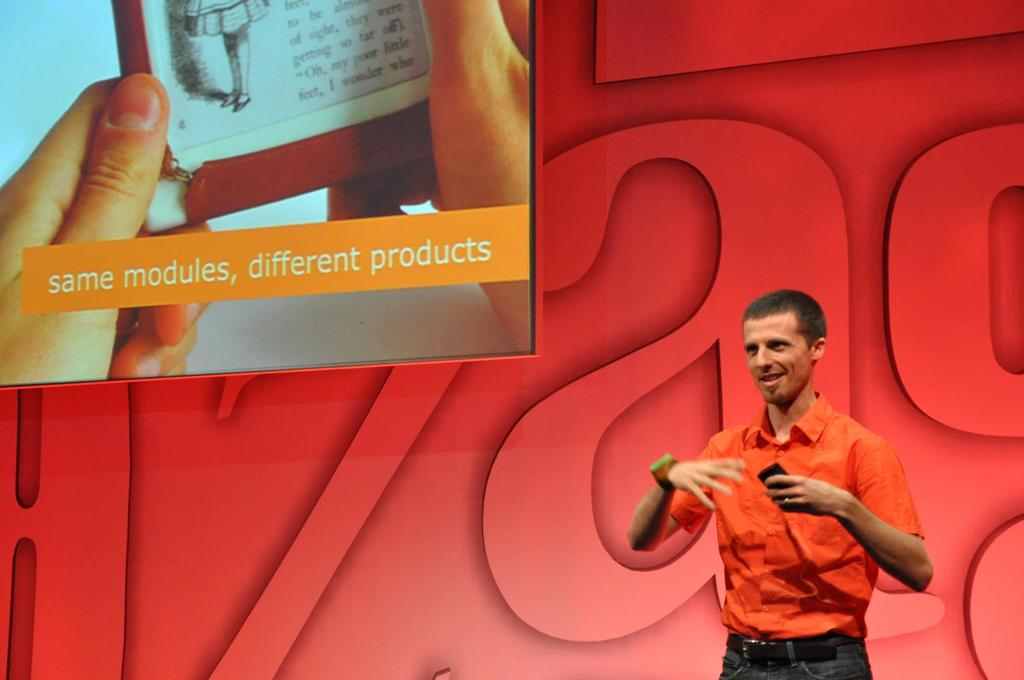Can you infer the possible setting or event where this presentation is taking place? The image shows a professional setting with a bold red backdrop and a large numeric '3' symbol, suggesting that this could be a technology conference or a product launch event where speakers share insights on innovation and product development. 